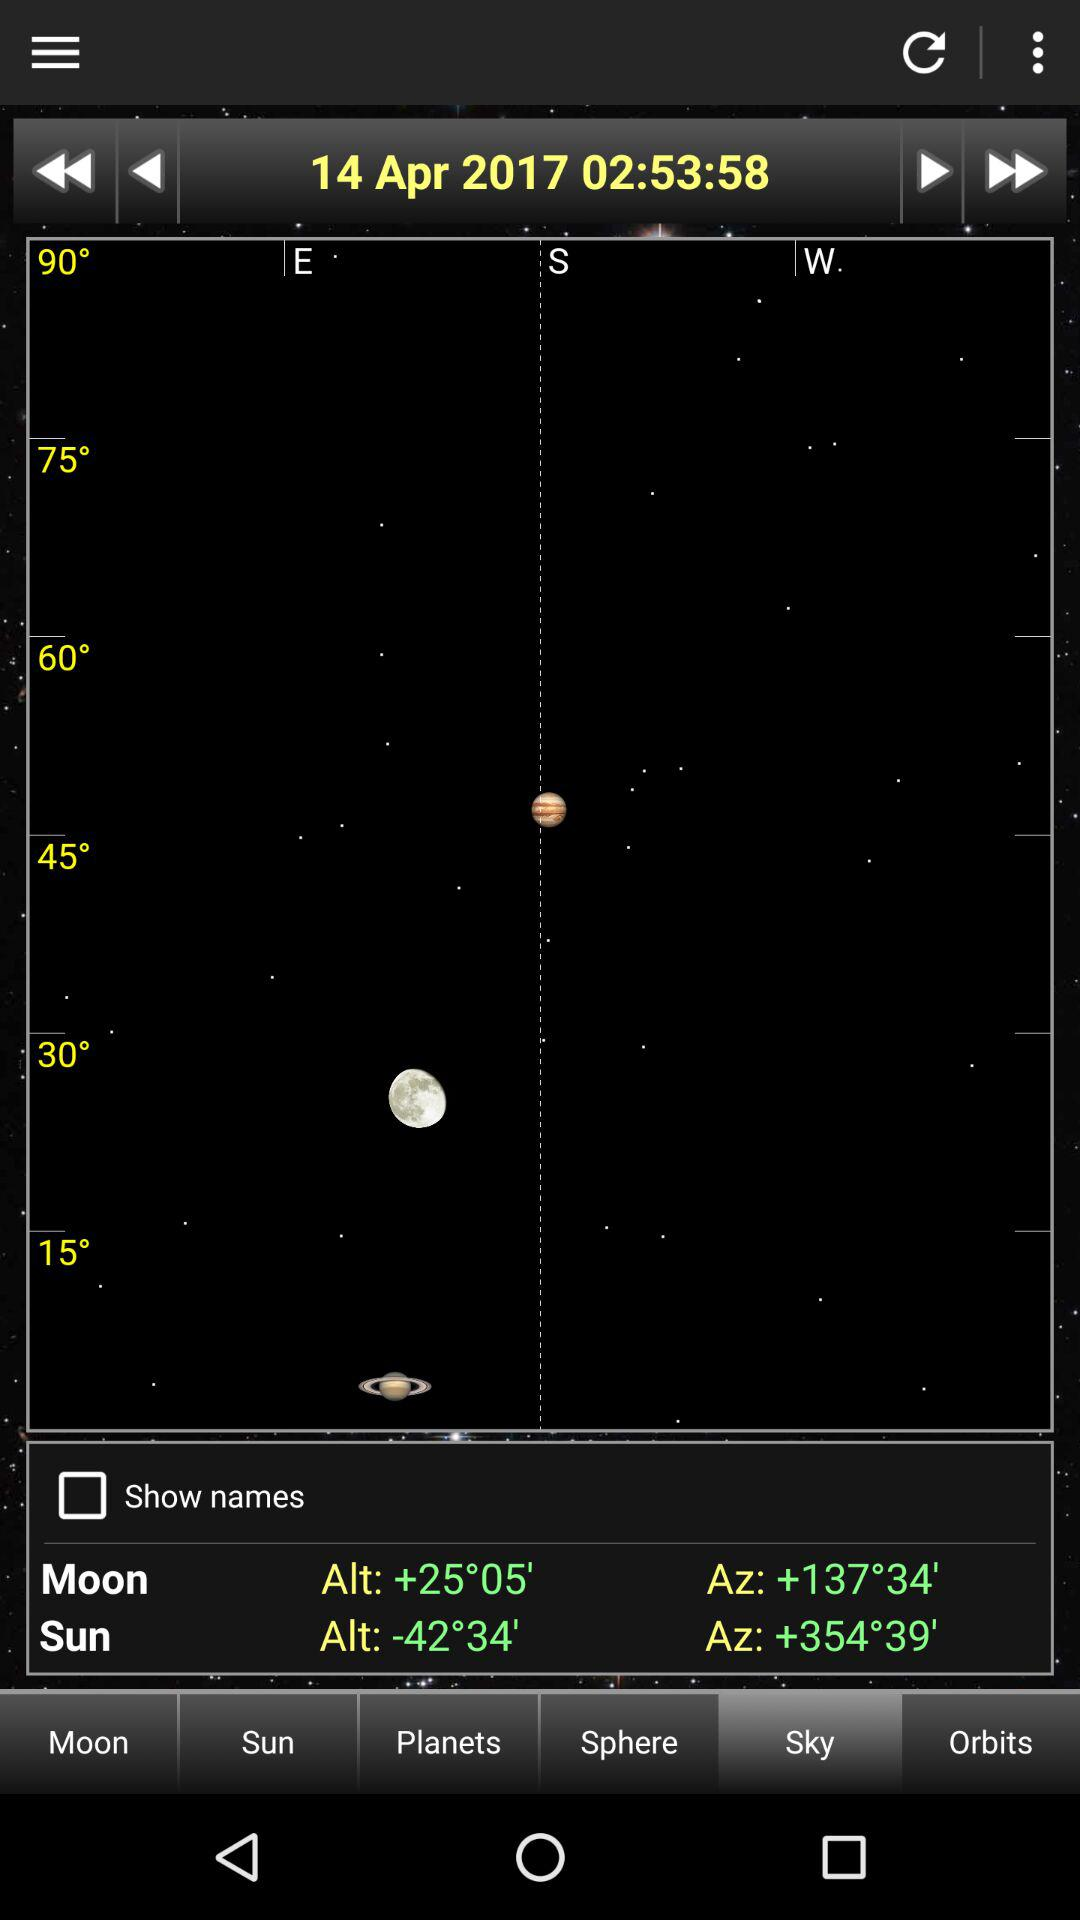What is the sun Alt value? The value is -42°34'. 